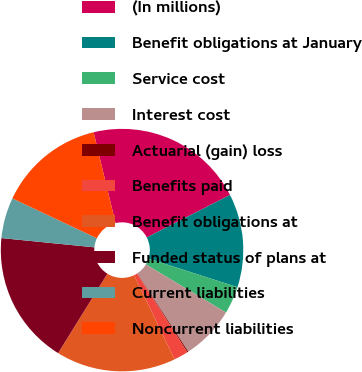<chart> <loc_0><loc_0><loc_500><loc_500><pie_chart><fcel>(In millions)<fcel>Benefit obligations at January<fcel>Service cost<fcel>Interest cost<fcel>Actuarial (gain) loss<fcel>Benefits paid<fcel>Benefit obligations at<fcel>Funded status of plans at<fcel>Current liabilities<fcel>Noncurrent liabilities<nl><fcel>21.26%<fcel>12.46%<fcel>3.67%<fcel>7.19%<fcel>0.15%<fcel>1.91%<fcel>15.98%<fcel>17.74%<fcel>5.43%<fcel>14.22%<nl></chart> 